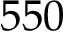<formula> <loc_0><loc_0><loc_500><loc_500>5 5 0</formula> 